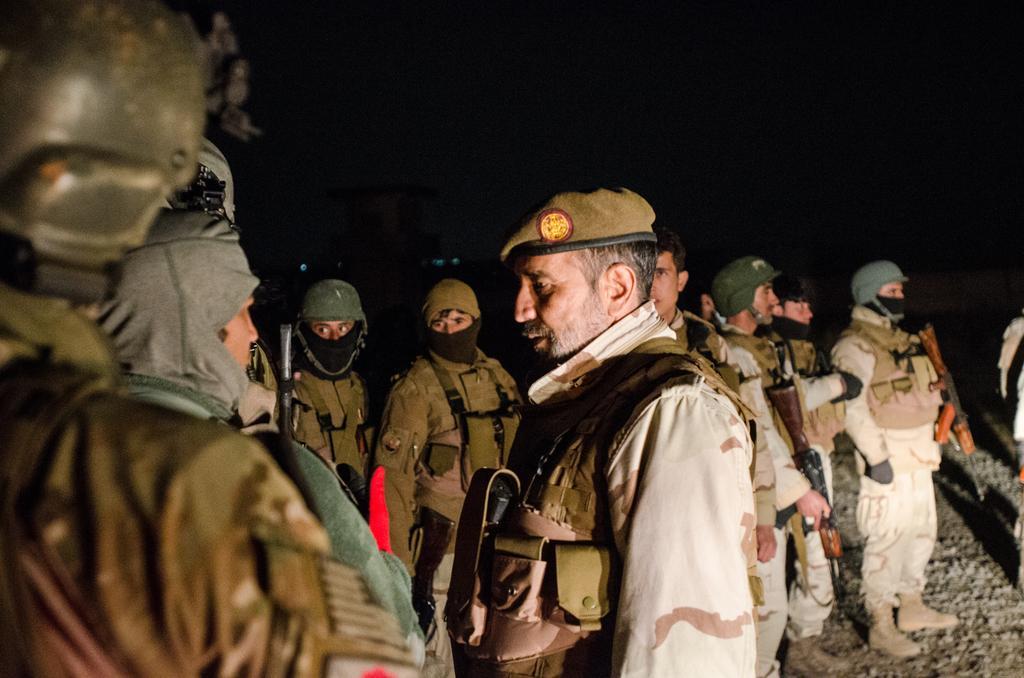In one or two sentences, can you explain what this image depicts? In this image there are some persons standing as we can see in middle of this image and the persons standing at right side is holding a weapons. 